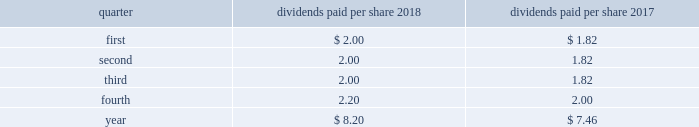Part ii item 5 .
Market for registrant 2019s common equity , related stockholder matters and issuer purchases of equity securities at january 25 , 2019 , we had 26812 holders of record of our common stock , par value $ 1 per share .
Our common stock is traded on the new york stock exchange ( nyse ) under the symbol lmt .
Information concerning dividends paid on lockheed martin common stock during the past two years is as follows : common stock - dividends paid per share .
Stockholder return performance graph the following graph compares the total return on a cumulative basis of $ 100 invested in lockheed martin common stock on december 31 , 2013 to the standard and poor 2019s ( s&p ) 500 index and the s&p aerospace & defense index .
The s&p aerospace & defense index comprises arconic inc. , general dynamics corporation , harris corporation , huntington ingalls industries , l3 technologies , inc. , lockheed martin corporation , northrop grumman corporation , raytheon company , textron inc. , the boeing company , transdigm group inc. , and united technologies corporation .
The stockholder return performance indicated on the graph is not a guarantee of future performance. .
What is the percentage change in total dividends paid per share from 2017 to 2018? 
Computations: ((8.20 - 7.46) / 7.46)
Answer: 0.0992. 